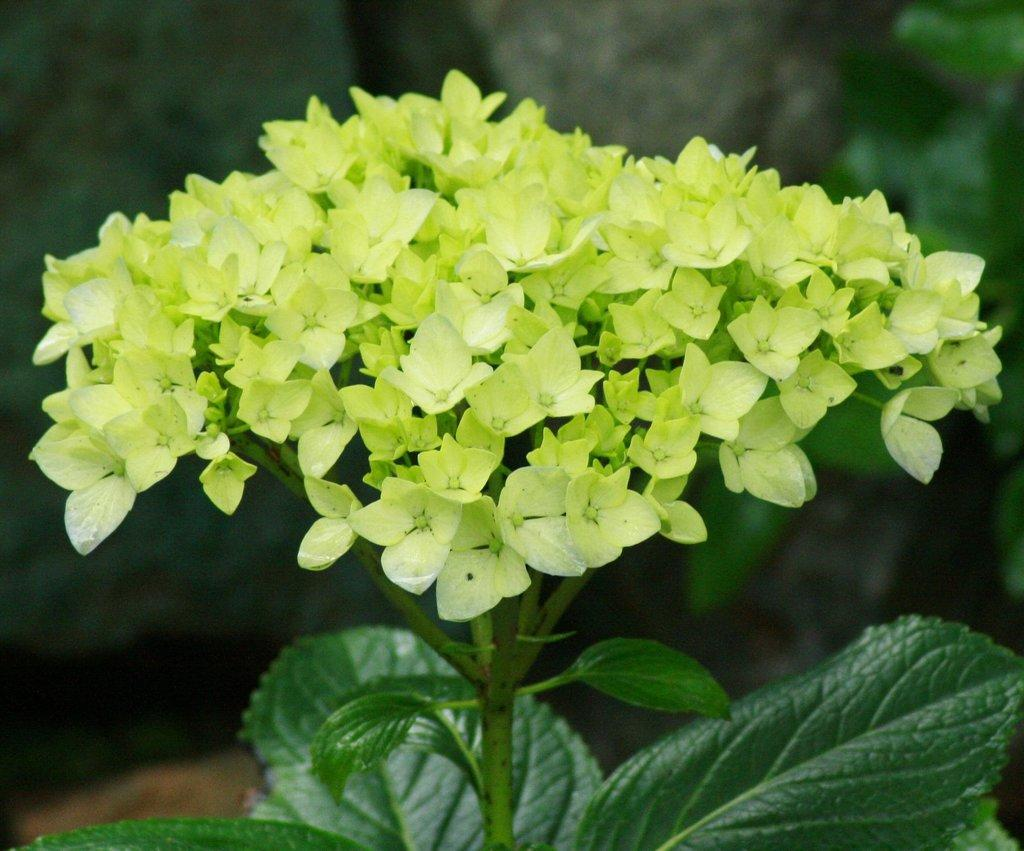What is located in the front of the image? There is a plant in the front of the image. What can be observed on the plant? There are leaves on the plant. How would you describe the background of the image? The background of the image is blurry. What type of operation is being performed on the plant in the image? There is no operation being performed on the plant in the image; it is simply a plant with leaves. 